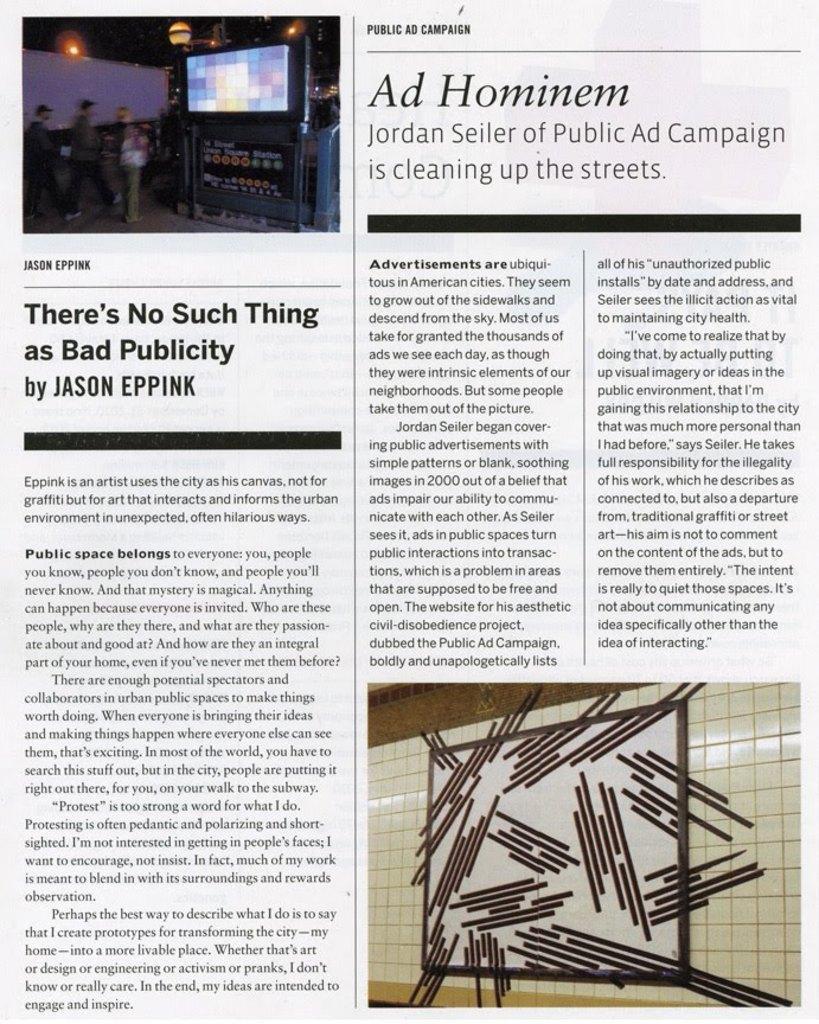In one or two sentences, can you explain what this image depicts? In the image we can see a paper, in the paper we can see some text and we can see a picture. In the picture we can see some people and screen. 